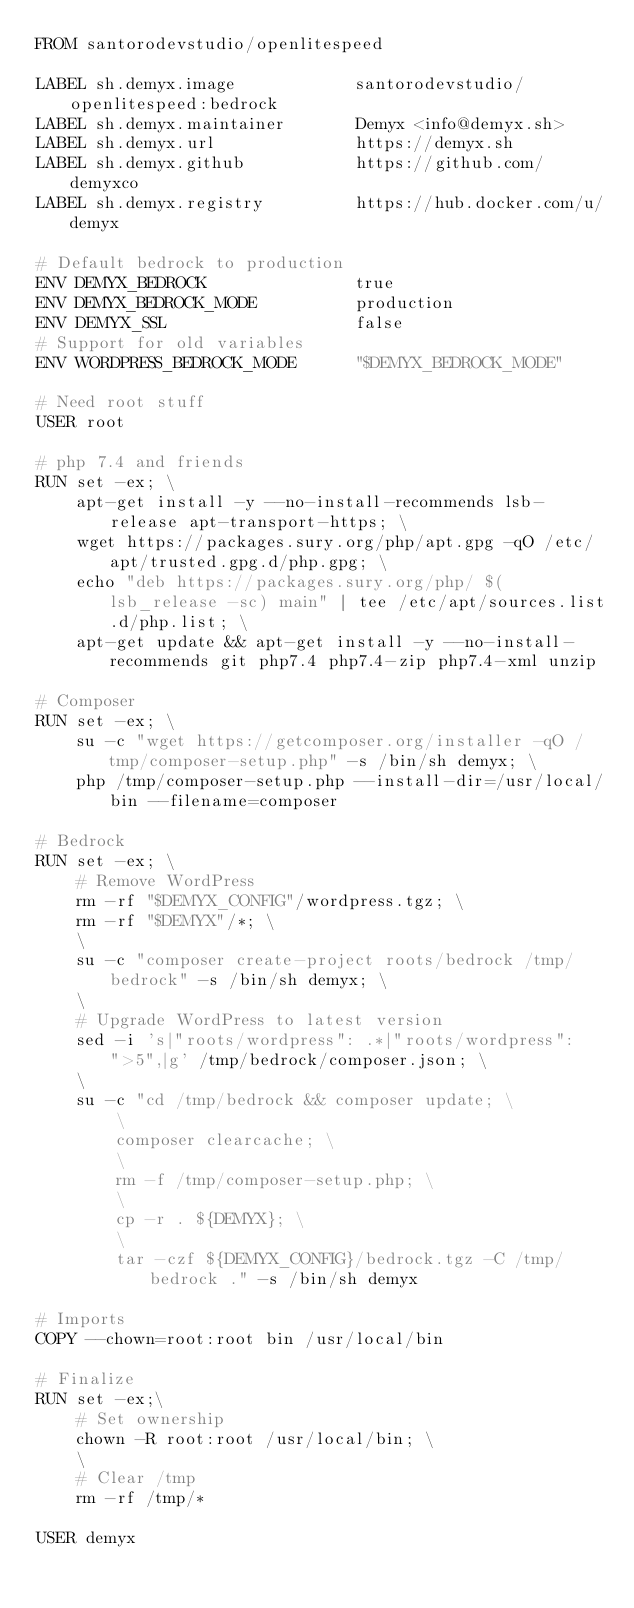<code> <loc_0><loc_0><loc_500><loc_500><_Dockerfile_>FROM santorodevstudio/openlitespeed

LABEL sh.demyx.image            santorodevstudio/openlitespeed:bedrock
LABEL sh.demyx.maintainer       Demyx <info@demyx.sh>
LABEL sh.demyx.url              https://demyx.sh
LABEL sh.demyx.github           https://github.com/demyxco
LABEL sh.demyx.registry         https://hub.docker.com/u/demyx

# Default bedrock to production
ENV DEMYX_BEDROCK               true
ENV DEMYX_BEDROCK_MODE          production
ENV DEMYX_SSL                   false
# Support for old variables
ENV WORDPRESS_BEDROCK_MODE      "$DEMYX_BEDROCK_MODE"

# Need root stuff
USER root

# php 7.4 and friends
RUN set -ex; \
    apt-get install -y --no-install-recommends lsb-release apt-transport-https; \
    wget https://packages.sury.org/php/apt.gpg -qO /etc/apt/trusted.gpg.d/php.gpg; \
    echo "deb https://packages.sury.org/php/ $(lsb_release -sc) main" | tee /etc/apt/sources.list.d/php.list; \
    apt-get update && apt-get install -y --no-install-recommends git php7.4 php7.4-zip php7.4-xml unzip

# Composer
RUN set -ex; \
    su -c "wget https://getcomposer.org/installer -qO /tmp/composer-setup.php" -s /bin/sh demyx; \
    php /tmp/composer-setup.php --install-dir=/usr/local/bin --filename=composer

# Bedrock
RUN set -ex; \
    # Remove WordPress
    rm -rf "$DEMYX_CONFIG"/wordpress.tgz; \
    rm -rf "$DEMYX"/*; \
    \
    su -c "composer create-project roots/bedrock /tmp/bedrock" -s /bin/sh demyx; \
    \
    # Upgrade WordPress to latest version
    sed -i 's|"roots/wordpress": .*|"roots/wordpress": ">5",|g' /tmp/bedrock/composer.json; \
    \
    su -c "cd /tmp/bedrock && composer update; \
        \
        composer clearcache; \
        \
        rm -f /tmp/composer-setup.php; \
        \
        cp -r . ${DEMYX}; \
        \
        tar -czf ${DEMYX_CONFIG}/bedrock.tgz -C /tmp/bedrock ." -s /bin/sh demyx

# Imports
COPY --chown=root:root bin /usr/local/bin

# Finalize
RUN set -ex;\
    # Set ownership
    chown -R root:root /usr/local/bin; \
    \
    # Clear /tmp
    rm -rf /tmp/*

USER demyx
</code> 